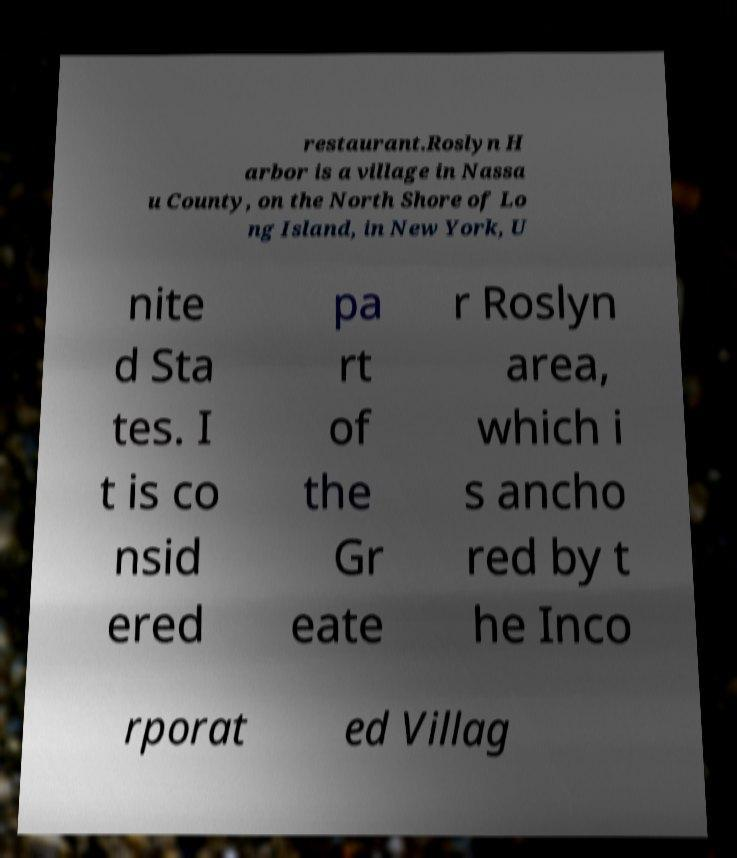Can you accurately transcribe the text from the provided image for me? restaurant.Roslyn H arbor is a village in Nassa u County, on the North Shore of Lo ng Island, in New York, U nite d Sta tes. I t is co nsid ered pa rt of the Gr eate r Roslyn area, which i s ancho red by t he Inco rporat ed Villag 